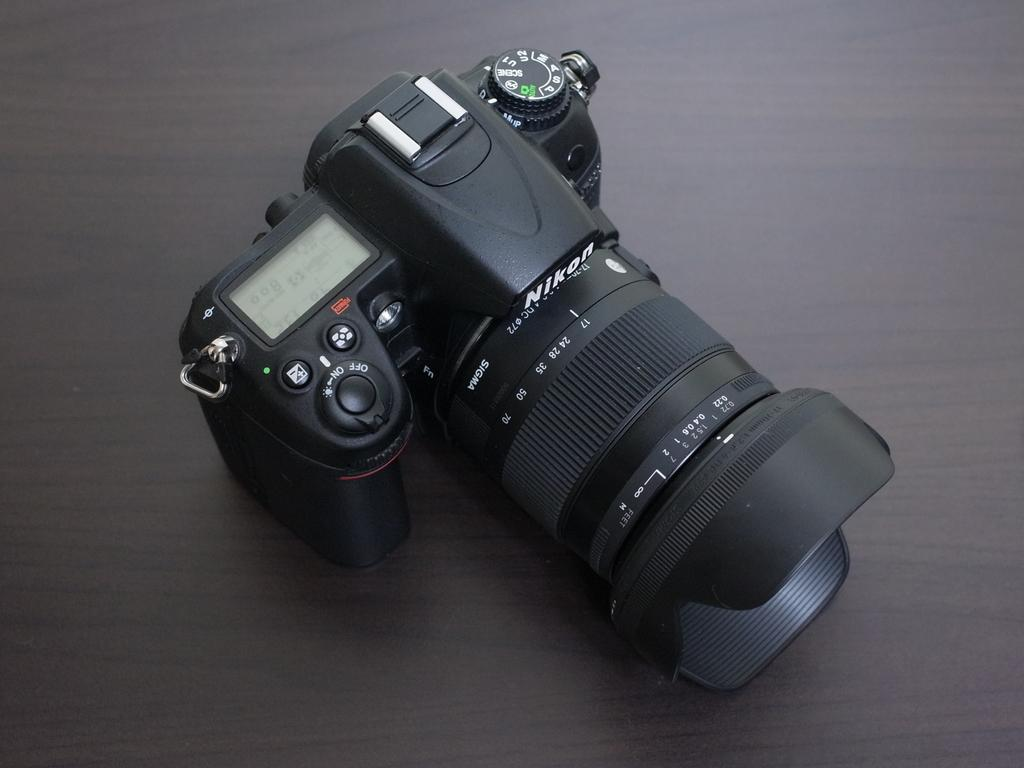<image>
Provide a brief description of the given image. A professional photo camera made by Nikon sits on a table 